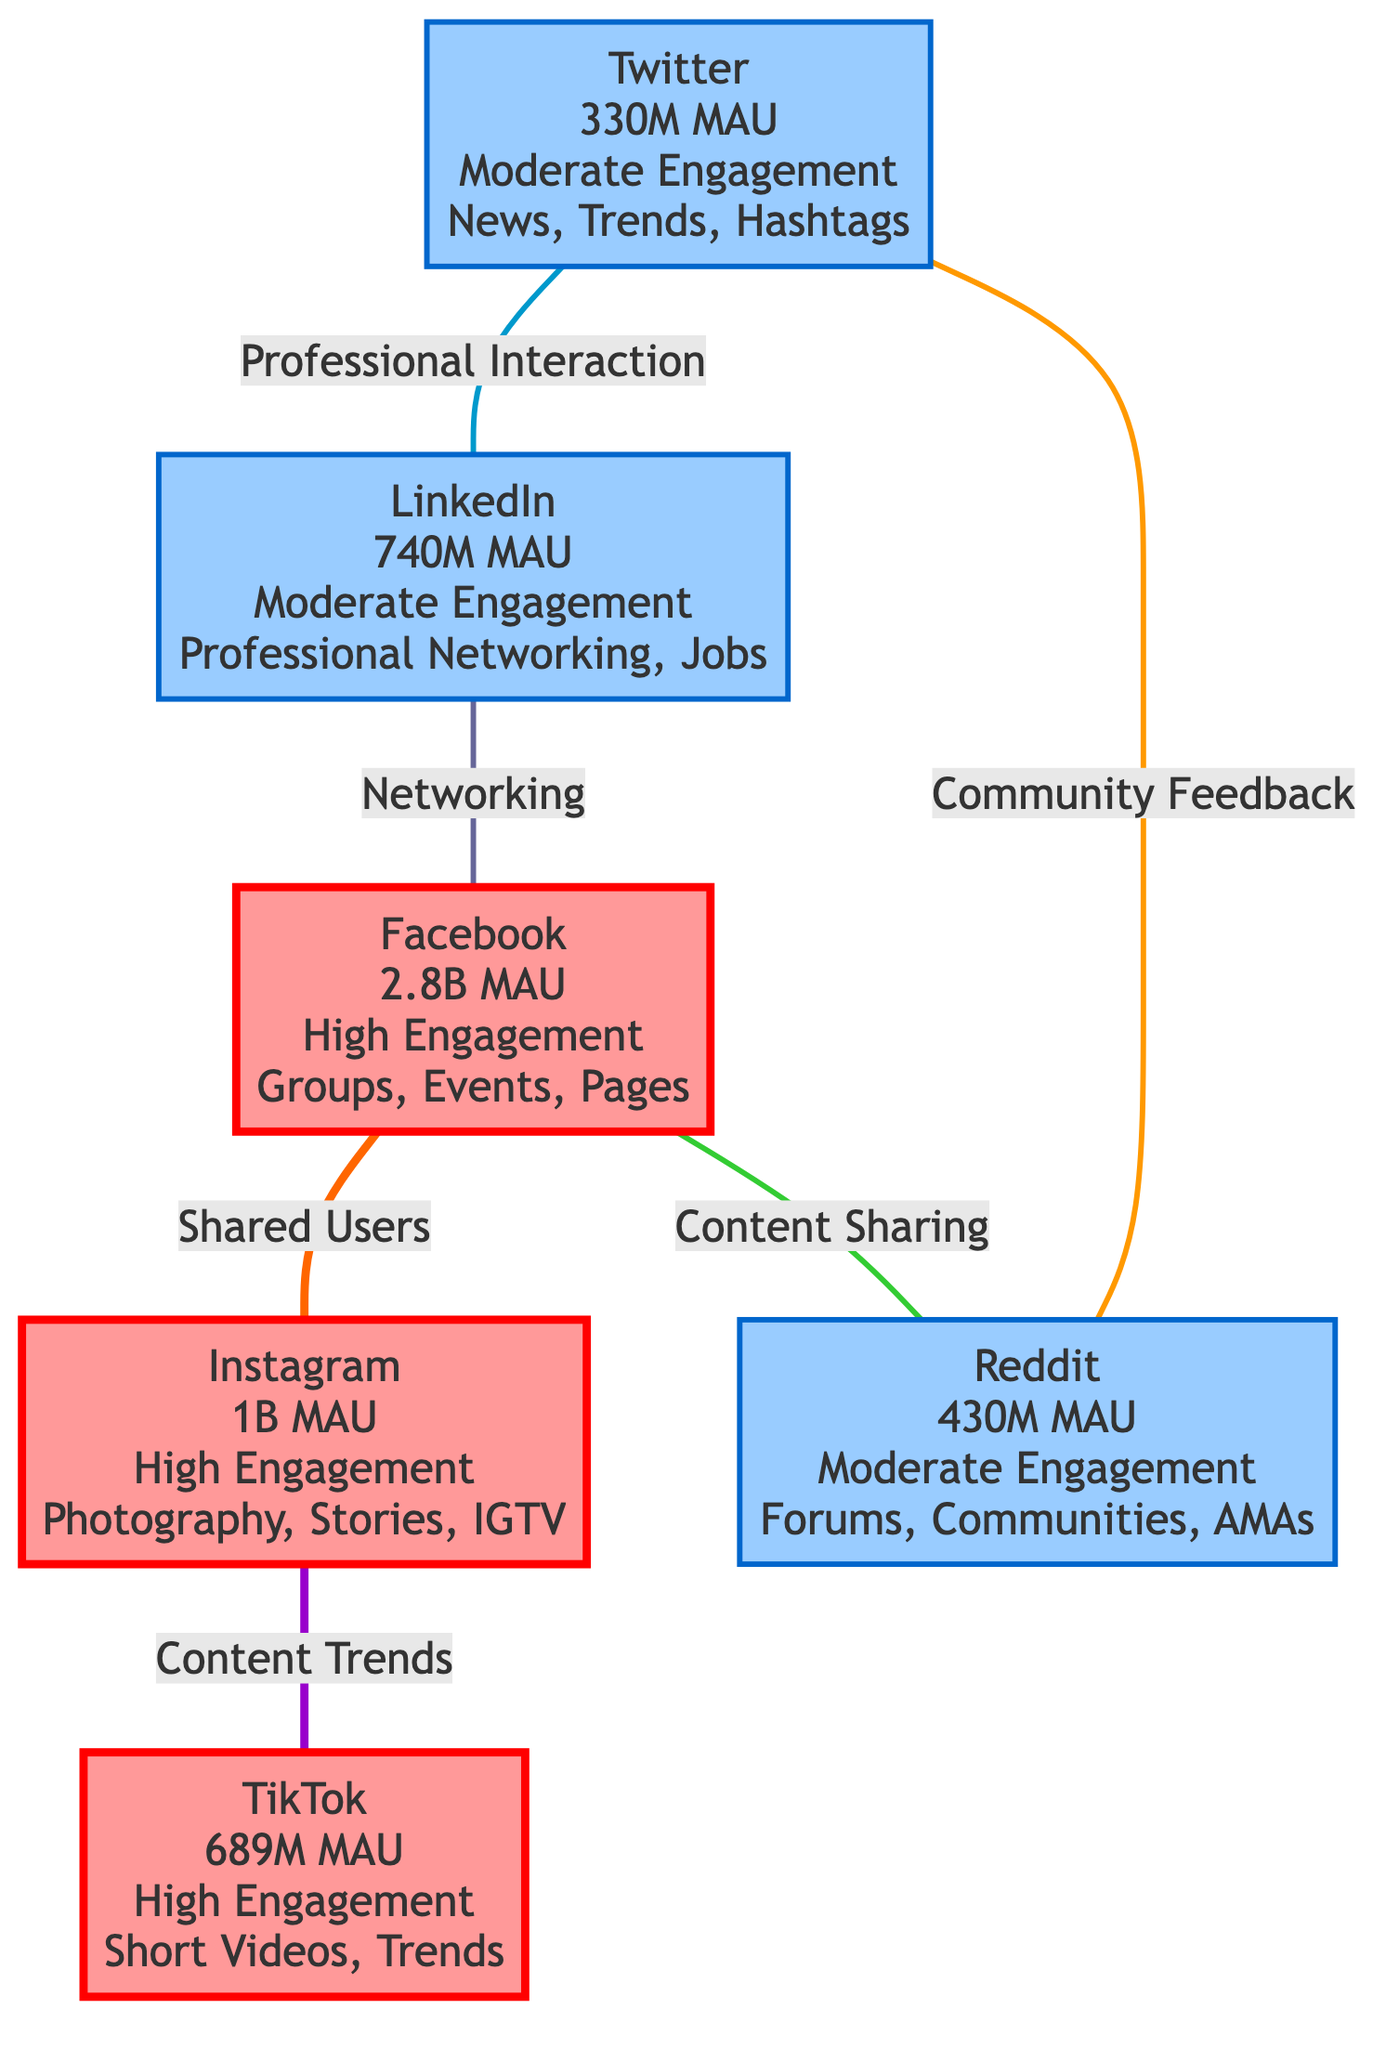What is the largest social media platform in terms of monthly active users? The diagram indicates that Facebook has 2.8 billion monthly active users (MAU), which is the highest among the listed platforms.
Answer: 2.8B MAU Which platform is associated with short videos? TikTok is specifically mentioned in the diagram as engaging users with short videos and trends.
Answer: TikTok What type of content is shared between Facebook and Reddit? The diagram describes the relationship between Facebook and Reddit as "Content Sharing," indicating they share user-generated content.
Answer: Content Sharing How many total platforms are represented in this diagram? By counting the nodes depicted, there are six distinct platforms shown in the diagram: Facebook, Instagram, Twitter, LinkedIn, Reddit, and TikTok.
Answer: 6 Which two platforms have a relationship involving professional networking? The diagram shows that LinkedIn and Facebook are connected through "Networking," indicating a professional interaction between these two platforms.
Answer: LinkedIn and Facebook Which social media platform has the lowest monthly active users? Twitter is identified in the diagram as having 330 million monthly active users, which is the lowest among the platforms listed.
Answer: 330M MAU What indicates high engagement on the platforms? The diagram clearly labels Facebook, Instagram, and TikTok as having "High Engagement," distinguishing them from the moderate engagement platforms.
Answer: High Engagement What relationship exists between Twitter and Reddit? The diagram indicates that Twitter has a relationship with Reddit labeled as "Community Feedback," showing an interactive connection focused on community responses.
Answer: Community Feedback How many platforms are classified as having moderate engagement? In the diagram, it categorizes Twitter, LinkedIn, and Reddit under "Moderate Engagement," thus totaling three platforms.
Answer: 3 